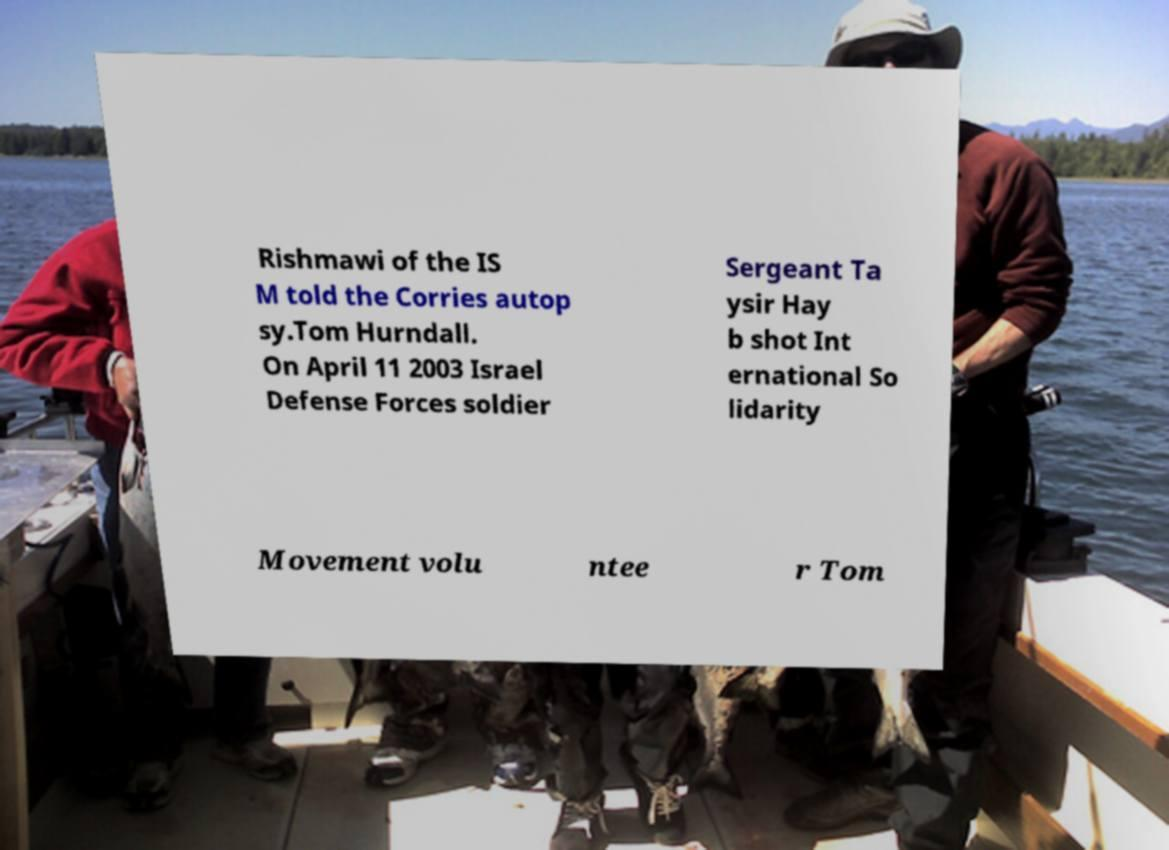For documentation purposes, I need the text within this image transcribed. Could you provide that? Rishmawi of the IS M told the Corries autop sy.Tom Hurndall. On April 11 2003 Israel Defense Forces soldier Sergeant Ta ysir Hay b shot Int ernational So lidarity Movement volu ntee r Tom 